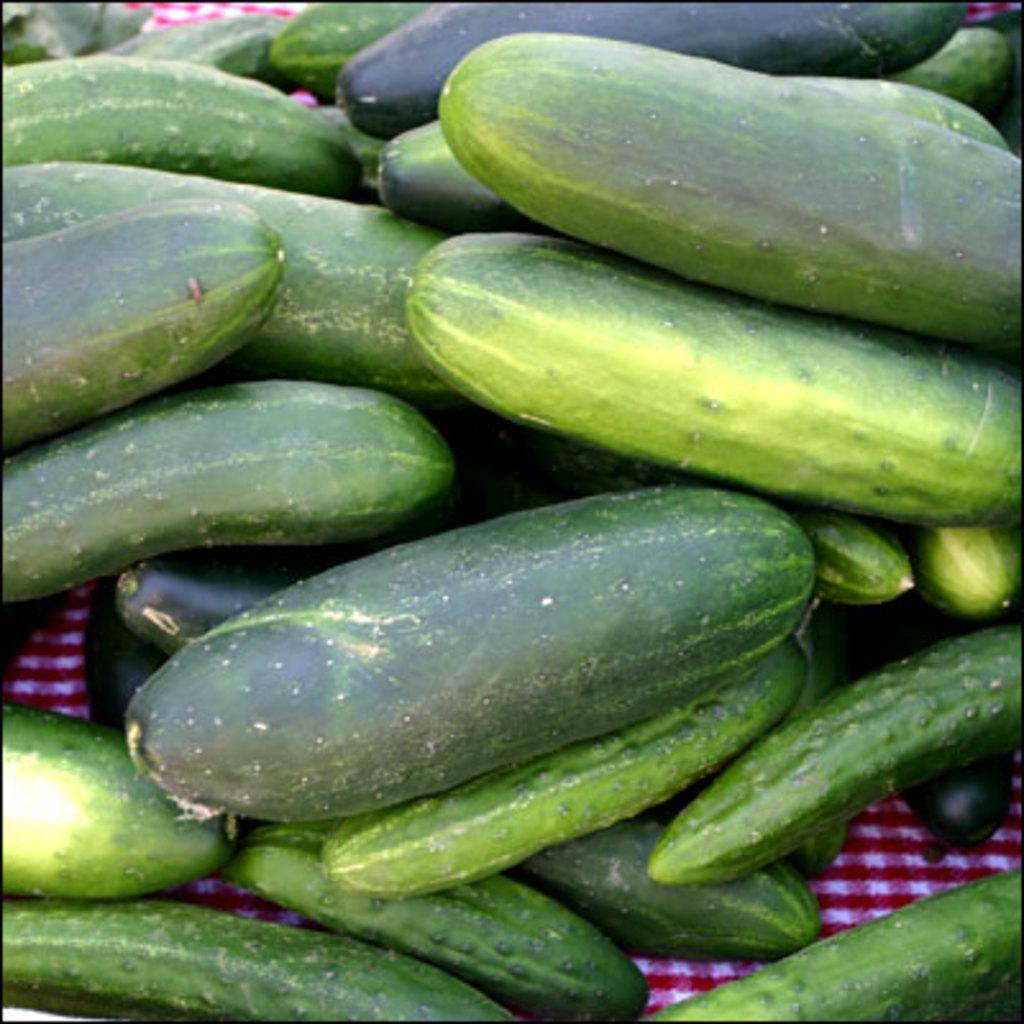What type of vegetable is present in the image? There are cucumbers in the image. What is located at the bottom of the image? There is a cloth at the bottom of the image. What type of church can be seen in the background of the image? There is no church present in the image; it only features cucumbers and a cloth. 